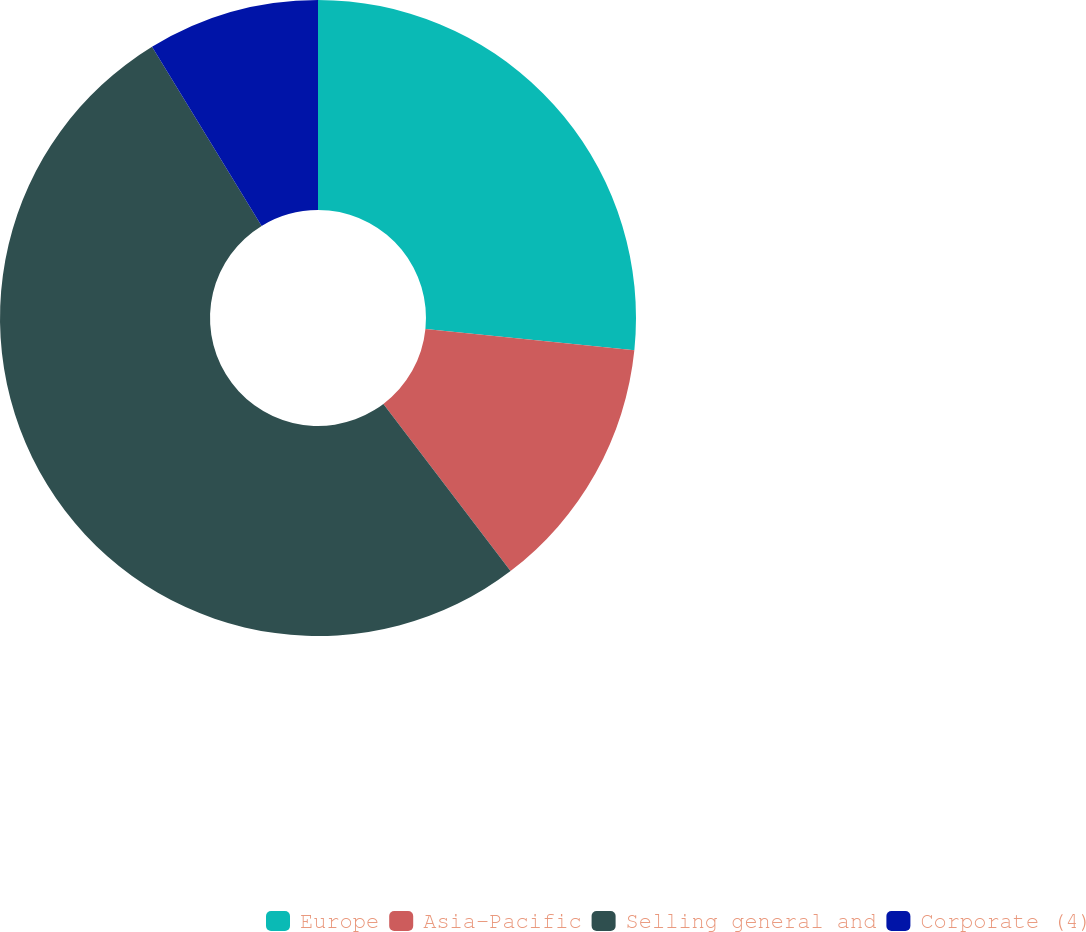Convert chart. <chart><loc_0><loc_0><loc_500><loc_500><pie_chart><fcel>Europe<fcel>Asia-Pacific<fcel>Selling general and<fcel>Corporate (4)<nl><fcel>26.62%<fcel>13.03%<fcel>51.61%<fcel>8.74%<nl></chart> 